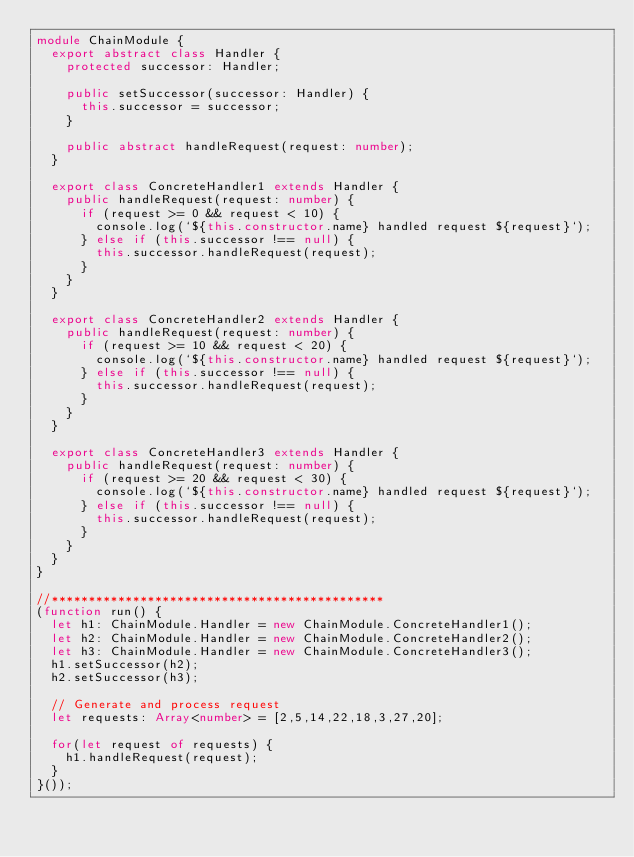Convert code to text. <code><loc_0><loc_0><loc_500><loc_500><_TypeScript_>module ChainModule {
  export abstract class Handler {
    protected successor: Handler;

    public setSuccessor(successor: Handler) {
      this.successor = successor;
    }

    public abstract handleRequest(request: number);
  }

  export class ConcreteHandler1 extends Handler {
    public handleRequest(request: number) {
      if (request >= 0 && request < 10) {
        console.log(`${this.constructor.name} handled request ${request}`);
      } else if (this.successor !== null) {
        this.successor.handleRequest(request);
      }
    }
  }

  export class ConcreteHandler2 extends Handler {
    public handleRequest(request: number) {
      if (request >= 10 && request < 20) {
        console.log(`${this.constructor.name} handled request ${request}`);
      } else if (this.successor !== null) {
        this.successor.handleRequest(request);
      }
    }
  }

  export class ConcreteHandler3 extends Handler {
    public handleRequest(request: number) {
      if (request >= 20 && request < 30) {
        console.log(`${this.constructor.name} handled request ${request}`);
      } else if (this.successor !== null) {
        this.successor.handleRequest(request);
      }
    }
  }
}

//*********************************************
(function run() {
  let h1: ChainModule.Handler = new ChainModule.ConcreteHandler1();
  let h2: ChainModule.Handler = new ChainModule.ConcreteHandler2();
  let h3: ChainModule.Handler = new ChainModule.ConcreteHandler3();
  h1.setSuccessor(h2);
  h2.setSuccessor(h3);

  // Generate and process request
  let requests: Array<number> = [2,5,14,22,18,3,27,20];

  for(let request of requests) {
    h1.handleRequest(request);
  }
}());</code> 